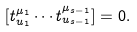<formula> <loc_0><loc_0><loc_500><loc_500>[ t _ { u _ { 1 } } ^ { \mu _ { 1 } } \cdots t _ { u _ { s - 1 } } ^ { \mu _ { s - 1 } } ] = 0 .</formula> 